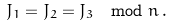<formula> <loc_0><loc_0><loc_500><loc_500>J _ { 1 } = J _ { 2 } = J _ { 3 } \mod n \, .</formula> 